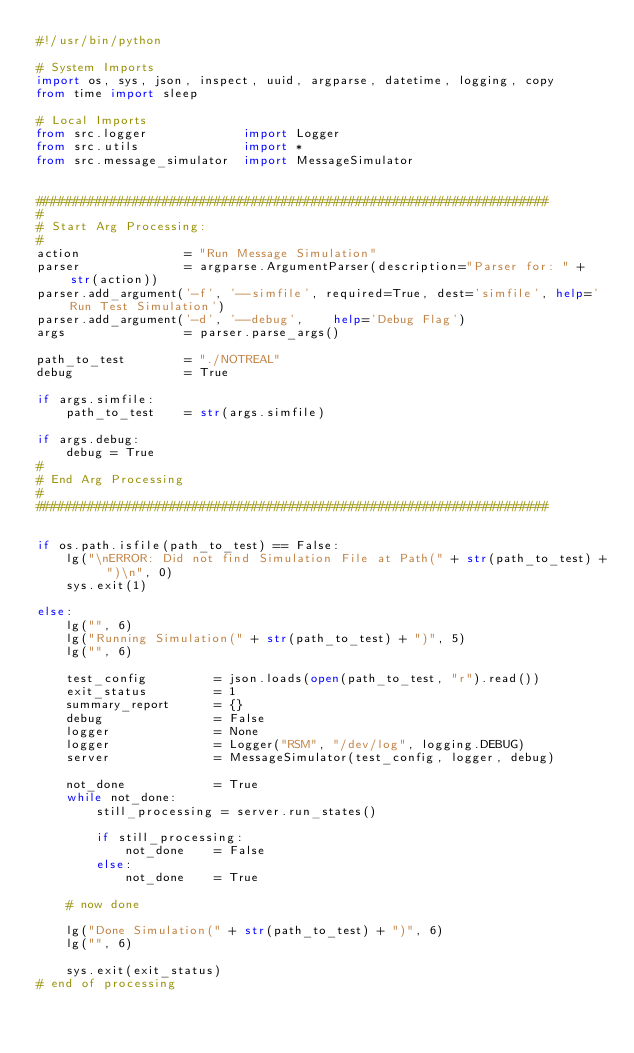<code> <loc_0><loc_0><loc_500><loc_500><_Python_>#!/usr/bin/python

# System Imports
import os, sys, json, inspect, uuid, argparse, datetime, logging, copy
from time import sleep

# Local Imports
from src.logger             import Logger
from src.utils              import *
from src.message_simulator  import MessageSimulator


#####################################################################
#
# Start Arg Processing:
#
action              = "Run Message Simulation"
parser              = argparse.ArgumentParser(description="Parser for: " + str(action))
parser.add_argument('-f', '--simfile', required=True, dest='simfile', help='Run Test Simulation')
parser.add_argument('-d', '--debug',    help='Debug Flag')
args                = parser.parse_args()

path_to_test        = "./NOTREAL"
debug               = True

if args.simfile:
    path_to_test    = str(args.simfile)

if args.debug:
    debug = True
#
# End Arg Processing
#
#####################################################################


if os.path.isfile(path_to_test) == False:
    lg("\nERROR: Did not find Simulation File at Path(" + str(path_to_test) + ")\n", 0)
    sys.exit(1) 

else:
    lg("", 6)
    lg("Running Simulation(" + str(path_to_test) + ")", 5)
    lg("", 6)

    test_config         = json.loads(open(path_to_test, "r").read())
    exit_status         = 1
    summary_report      = {}
    debug               = False
    logger              = None
    logger              = Logger("RSM", "/dev/log", logging.DEBUG)
    server              = MessageSimulator(test_config, logger, debug)

    not_done            = True
    while not_done:
        still_processing = server.run_states()

        if still_processing:
            not_done    = False
        else:
            not_done    = True

    # now done
    
    lg("Done Simulation(" + str(path_to_test) + ")", 6)
    lg("", 6)

    sys.exit(exit_status)
# end of processing










</code> 